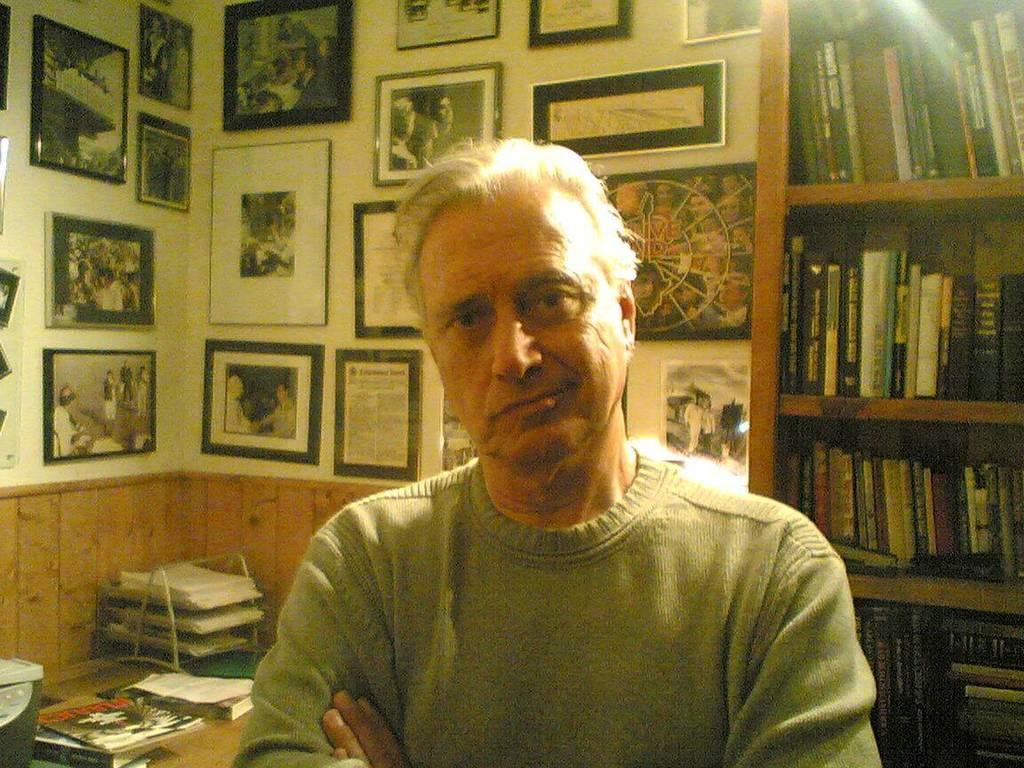Can you describe this image briefly? In this picture there is a man who is standing in the center of the image and there is a bookshelf on the right side of the image and there are portraits on the wall and there are books on the desk at the bottom side of the image. 